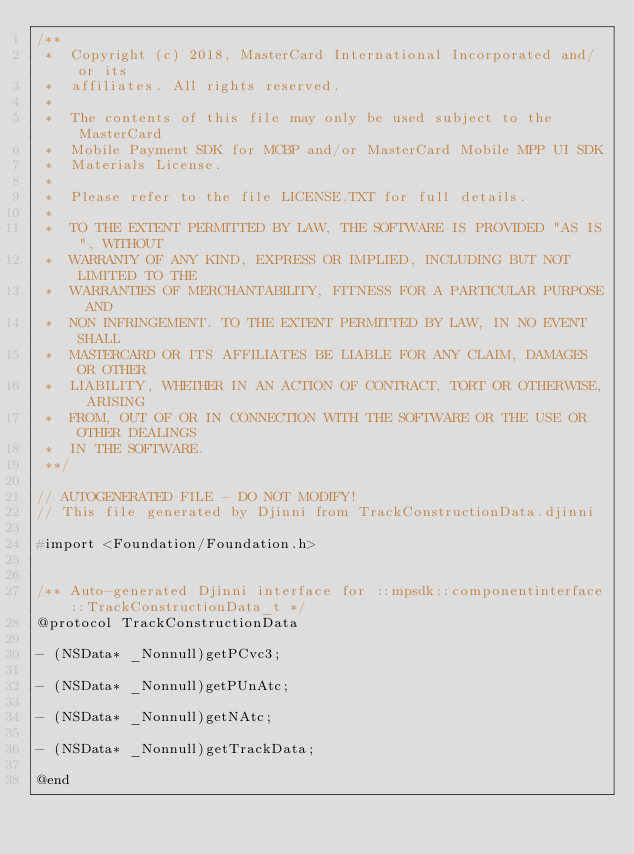Convert code to text. <code><loc_0><loc_0><loc_500><loc_500><_C_>/**
 *  Copyright (c) 2018, MasterCard International Incorporated and/or its
 *  affiliates. All rights reserved.
 *
 *  The contents of this file may only be used subject to the MasterCard
 *  Mobile Payment SDK for MCBP and/or MasterCard Mobile MPP UI SDK
 *  Materials License.
 *
 *  Please refer to the file LICENSE.TXT for full details.
 *
 *  TO THE EXTENT PERMITTED BY LAW, THE SOFTWARE IS PROVIDED "AS IS", WITHOUT
 *  WARRANTY OF ANY KIND, EXPRESS OR IMPLIED, INCLUDING BUT NOT LIMITED TO THE
 *  WARRANTIES OF MERCHANTABILITY, FITNESS FOR A PARTICULAR PURPOSE AND
 *  NON INFRINGEMENT. TO THE EXTENT PERMITTED BY LAW, IN NO EVENT SHALL
 *  MASTERCARD OR ITS AFFILIATES BE LIABLE FOR ANY CLAIM, DAMAGES OR OTHER
 *  LIABILITY, WHETHER IN AN ACTION OF CONTRACT, TORT OR OTHERWISE, ARISING
 *  FROM, OUT OF OR IN CONNECTION WITH THE SOFTWARE OR THE USE OR OTHER DEALINGS
 *  IN THE SOFTWARE.
 **/

// AUTOGENERATED FILE - DO NOT MODIFY!
// This file generated by Djinni from TrackConstructionData.djinni

#import <Foundation/Foundation.h>


/** Auto-generated Djinni interface for ::mpsdk::componentinterface::TrackConstructionData_t */
@protocol TrackConstructionData

- (NSData* _Nonnull)getPCvc3;

- (NSData* _Nonnull)getPUnAtc;

- (NSData* _Nonnull)getNAtc;

- (NSData* _Nonnull)getTrackData;

@end
</code> 